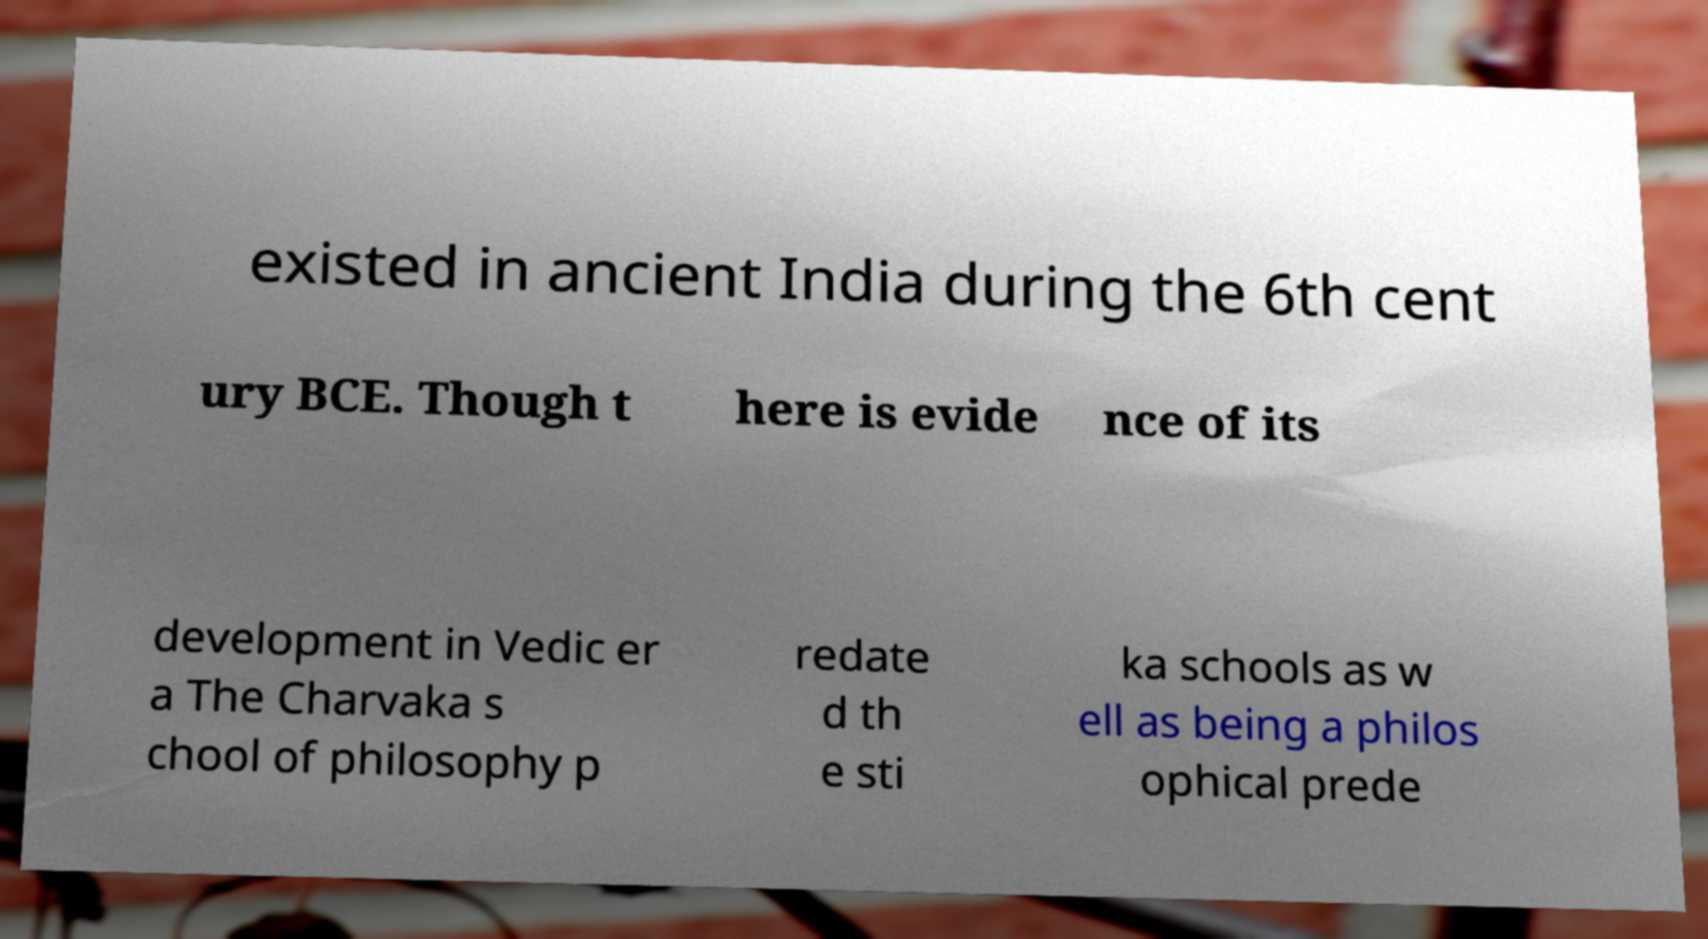I need the written content from this picture converted into text. Can you do that? existed in ancient India during the 6th cent ury BCE. Though t here is evide nce of its development in Vedic er a The Charvaka s chool of philosophy p redate d th e sti ka schools as w ell as being a philos ophical prede 